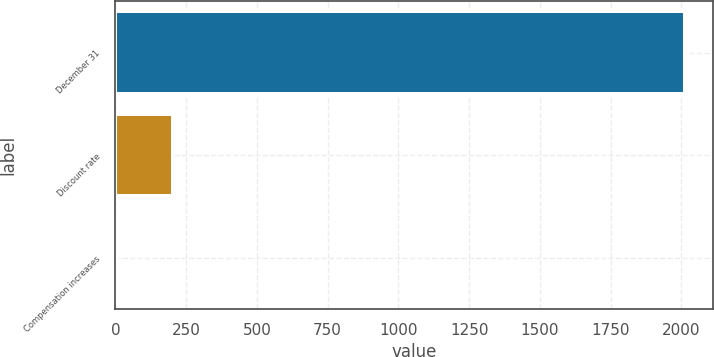<chart> <loc_0><loc_0><loc_500><loc_500><bar_chart><fcel>December 31<fcel>Discount rate<fcel>Compensation increases<nl><fcel>2013<fcel>204.68<fcel>3.76<nl></chart> 